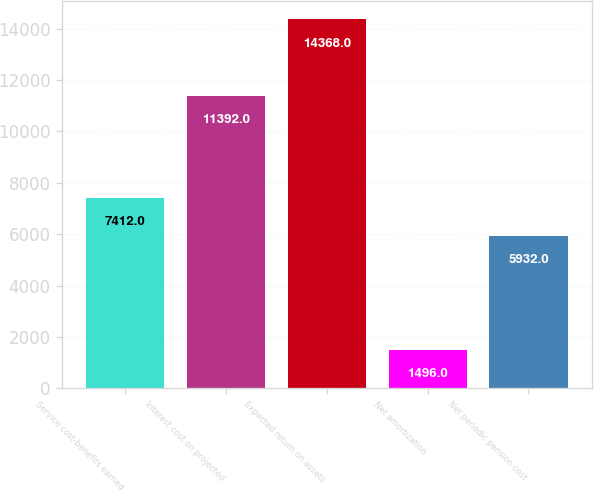Convert chart. <chart><loc_0><loc_0><loc_500><loc_500><bar_chart><fcel>Service cost-benefits earned<fcel>Interest cost on projected<fcel>Expected return on assets<fcel>Net amortization<fcel>Net periodic pension cost<nl><fcel>7412<fcel>11392<fcel>14368<fcel>1496<fcel>5932<nl></chart> 